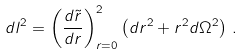Convert formula to latex. <formula><loc_0><loc_0><loc_500><loc_500>d l ^ { 2 } = \left ( \frac { d \tilde { r } } { d r } \right ) ^ { 2 } _ { r = 0 } \left ( d r ^ { 2 } + r ^ { 2 } d \Omega ^ { 2 } \right ) \, .</formula> 